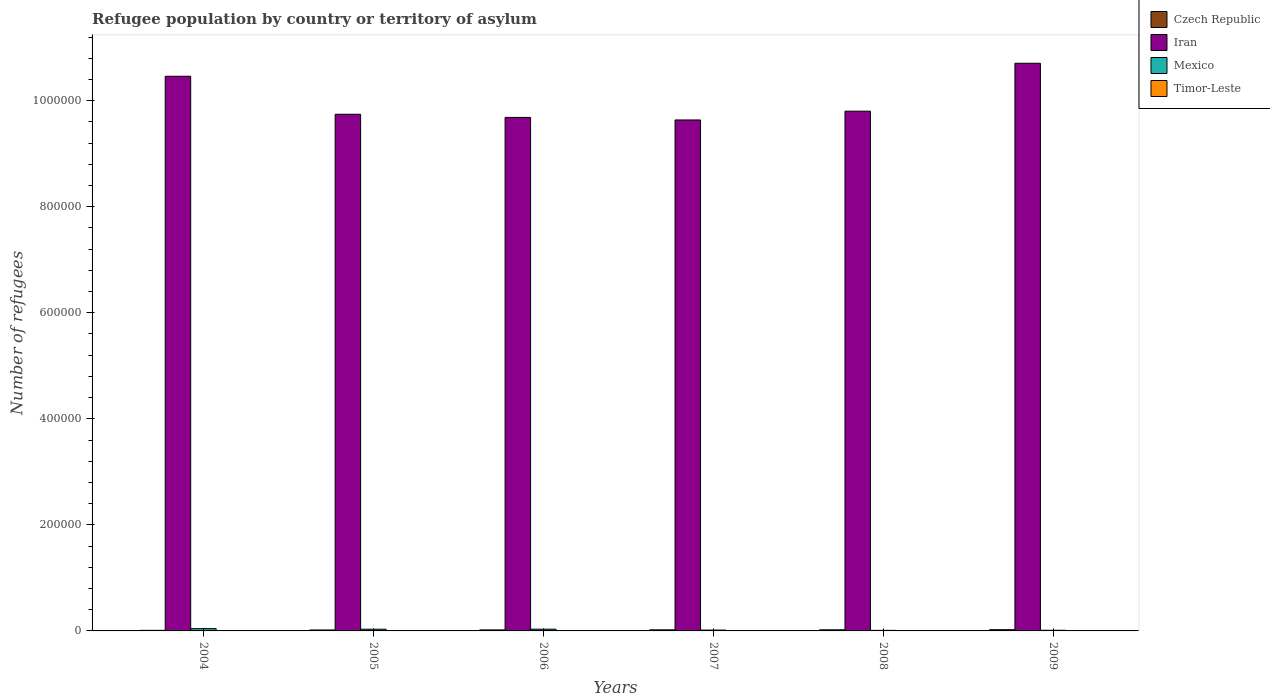How many different coloured bars are there?
Your answer should be very brief. 4. What is the label of the 4th group of bars from the left?
Offer a very short reply. 2007. What is the number of refugees in Czech Republic in 2007?
Offer a very short reply. 2037. Across all years, what is the minimum number of refugees in Mexico?
Offer a very short reply. 1055. In which year was the number of refugees in Iran maximum?
Offer a terse response. 2009. In which year was the number of refugees in Iran minimum?
Offer a terse response. 2007. What is the total number of refugees in Mexico in the graph?
Offer a very short reply. 1.48e+04. What is the difference between the number of refugees in Iran in 2006 and the number of refugees in Czech Republic in 2004?
Provide a short and direct response. 9.67e+05. What is the average number of refugees in Mexico per year?
Make the answer very short. 2466.17. In the year 2005, what is the difference between the number of refugees in Mexico and number of refugees in Timor-Leste?
Keep it short and to the point. 3226. What is the ratio of the number of refugees in Czech Republic in 2008 to that in 2009?
Offer a terse response. 0.91. Is the number of refugees in Iran in 2004 less than that in 2008?
Your response must be concise. No. Is the difference between the number of refugees in Mexico in 2006 and 2009 greater than the difference between the number of refugees in Timor-Leste in 2006 and 2009?
Give a very brief answer. Yes. What is the difference between the highest and the second highest number of refugees in Czech Republic?
Offer a terse response. 213. What is the difference between the highest and the lowest number of refugees in Mexico?
Provide a short and direct response. 3288. Is the sum of the number of refugees in Timor-Leste in 2007 and 2008 greater than the maximum number of refugees in Iran across all years?
Provide a succinct answer. No. Is it the case that in every year, the sum of the number of refugees in Czech Republic and number of refugees in Iran is greater than the sum of number of refugees in Mexico and number of refugees in Timor-Leste?
Your answer should be very brief. Yes. What does the 1st bar from the left in 2004 represents?
Give a very brief answer. Czech Republic. What is the difference between two consecutive major ticks on the Y-axis?
Make the answer very short. 2.00e+05. Are the values on the major ticks of Y-axis written in scientific E-notation?
Keep it short and to the point. No. Does the graph contain grids?
Provide a succinct answer. No. What is the title of the graph?
Make the answer very short. Refugee population by country or territory of asylum. What is the label or title of the X-axis?
Provide a succinct answer. Years. What is the label or title of the Y-axis?
Your response must be concise. Number of refugees. What is the Number of refugees in Czech Republic in 2004?
Your answer should be very brief. 1144. What is the Number of refugees of Iran in 2004?
Your response must be concise. 1.05e+06. What is the Number of refugees in Mexico in 2004?
Offer a terse response. 4343. What is the Number of refugees of Timor-Leste in 2004?
Make the answer very short. 3. What is the Number of refugees of Czech Republic in 2005?
Offer a terse response. 1802. What is the Number of refugees of Iran in 2005?
Your answer should be very brief. 9.74e+05. What is the Number of refugees of Mexico in 2005?
Provide a succinct answer. 3229. What is the Number of refugees in Czech Republic in 2006?
Offer a terse response. 1887. What is the Number of refugees of Iran in 2006?
Keep it short and to the point. 9.68e+05. What is the Number of refugees in Mexico in 2006?
Your response must be concise. 3319. What is the Number of refugees in Timor-Leste in 2006?
Your answer should be compact. 3. What is the Number of refugees in Czech Republic in 2007?
Your response must be concise. 2037. What is the Number of refugees in Iran in 2007?
Give a very brief answer. 9.64e+05. What is the Number of refugees of Mexico in 2007?
Provide a short and direct response. 1616. What is the Number of refugees of Timor-Leste in 2007?
Give a very brief answer. 1. What is the Number of refugees of Czech Republic in 2008?
Ensure brevity in your answer.  2110. What is the Number of refugees in Iran in 2008?
Your answer should be very brief. 9.80e+05. What is the Number of refugees of Mexico in 2008?
Give a very brief answer. 1055. What is the Number of refugees of Timor-Leste in 2008?
Keep it short and to the point. 1. What is the Number of refugees in Czech Republic in 2009?
Provide a short and direct response. 2323. What is the Number of refugees in Iran in 2009?
Give a very brief answer. 1.07e+06. What is the Number of refugees in Mexico in 2009?
Your answer should be very brief. 1235. What is the Number of refugees in Timor-Leste in 2009?
Your answer should be compact. 1. Across all years, what is the maximum Number of refugees of Czech Republic?
Provide a short and direct response. 2323. Across all years, what is the maximum Number of refugees in Iran?
Keep it short and to the point. 1.07e+06. Across all years, what is the maximum Number of refugees of Mexico?
Provide a short and direct response. 4343. Across all years, what is the minimum Number of refugees in Czech Republic?
Your answer should be very brief. 1144. Across all years, what is the minimum Number of refugees in Iran?
Offer a very short reply. 9.64e+05. Across all years, what is the minimum Number of refugees of Mexico?
Ensure brevity in your answer.  1055. Across all years, what is the minimum Number of refugees in Timor-Leste?
Your answer should be very brief. 1. What is the total Number of refugees in Czech Republic in the graph?
Offer a very short reply. 1.13e+04. What is the total Number of refugees in Iran in the graph?
Your answer should be compact. 6.00e+06. What is the total Number of refugees of Mexico in the graph?
Your response must be concise. 1.48e+04. What is the difference between the Number of refugees in Czech Republic in 2004 and that in 2005?
Your answer should be compact. -658. What is the difference between the Number of refugees of Iran in 2004 and that in 2005?
Provide a succinct answer. 7.17e+04. What is the difference between the Number of refugees in Mexico in 2004 and that in 2005?
Ensure brevity in your answer.  1114. What is the difference between the Number of refugees of Czech Republic in 2004 and that in 2006?
Ensure brevity in your answer.  -743. What is the difference between the Number of refugees of Iran in 2004 and that in 2006?
Your answer should be compact. 7.76e+04. What is the difference between the Number of refugees of Mexico in 2004 and that in 2006?
Make the answer very short. 1024. What is the difference between the Number of refugees of Timor-Leste in 2004 and that in 2006?
Ensure brevity in your answer.  0. What is the difference between the Number of refugees in Czech Republic in 2004 and that in 2007?
Your answer should be compact. -893. What is the difference between the Number of refugees of Iran in 2004 and that in 2007?
Make the answer very short. 8.24e+04. What is the difference between the Number of refugees in Mexico in 2004 and that in 2007?
Ensure brevity in your answer.  2727. What is the difference between the Number of refugees of Czech Republic in 2004 and that in 2008?
Give a very brief answer. -966. What is the difference between the Number of refugees of Iran in 2004 and that in 2008?
Offer a terse response. 6.59e+04. What is the difference between the Number of refugees of Mexico in 2004 and that in 2008?
Provide a short and direct response. 3288. What is the difference between the Number of refugees in Timor-Leste in 2004 and that in 2008?
Keep it short and to the point. 2. What is the difference between the Number of refugees of Czech Republic in 2004 and that in 2009?
Provide a short and direct response. -1179. What is the difference between the Number of refugees in Iran in 2004 and that in 2009?
Offer a very short reply. -2.45e+04. What is the difference between the Number of refugees in Mexico in 2004 and that in 2009?
Your answer should be compact. 3108. What is the difference between the Number of refugees of Czech Republic in 2005 and that in 2006?
Give a very brief answer. -85. What is the difference between the Number of refugees in Iran in 2005 and that in 2006?
Ensure brevity in your answer.  5932. What is the difference between the Number of refugees in Mexico in 2005 and that in 2006?
Provide a succinct answer. -90. What is the difference between the Number of refugees in Timor-Leste in 2005 and that in 2006?
Offer a terse response. 0. What is the difference between the Number of refugees of Czech Republic in 2005 and that in 2007?
Provide a short and direct response. -235. What is the difference between the Number of refugees of Iran in 2005 and that in 2007?
Offer a very short reply. 1.08e+04. What is the difference between the Number of refugees in Mexico in 2005 and that in 2007?
Give a very brief answer. 1613. What is the difference between the Number of refugees of Czech Republic in 2005 and that in 2008?
Provide a succinct answer. -308. What is the difference between the Number of refugees of Iran in 2005 and that in 2008?
Your response must be concise. -5807. What is the difference between the Number of refugees in Mexico in 2005 and that in 2008?
Your answer should be very brief. 2174. What is the difference between the Number of refugees of Timor-Leste in 2005 and that in 2008?
Make the answer very short. 2. What is the difference between the Number of refugees in Czech Republic in 2005 and that in 2009?
Ensure brevity in your answer.  -521. What is the difference between the Number of refugees in Iran in 2005 and that in 2009?
Provide a short and direct response. -9.62e+04. What is the difference between the Number of refugees in Mexico in 2005 and that in 2009?
Make the answer very short. 1994. What is the difference between the Number of refugees in Timor-Leste in 2005 and that in 2009?
Make the answer very short. 2. What is the difference between the Number of refugees of Czech Republic in 2006 and that in 2007?
Offer a very short reply. -150. What is the difference between the Number of refugees of Iran in 2006 and that in 2007?
Offer a very short reply. 4824. What is the difference between the Number of refugees in Mexico in 2006 and that in 2007?
Your answer should be compact. 1703. What is the difference between the Number of refugees of Timor-Leste in 2006 and that in 2007?
Make the answer very short. 2. What is the difference between the Number of refugees in Czech Republic in 2006 and that in 2008?
Your response must be concise. -223. What is the difference between the Number of refugees in Iran in 2006 and that in 2008?
Give a very brief answer. -1.17e+04. What is the difference between the Number of refugees of Mexico in 2006 and that in 2008?
Your answer should be compact. 2264. What is the difference between the Number of refugees in Timor-Leste in 2006 and that in 2008?
Your answer should be compact. 2. What is the difference between the Number of refugees of Czech Republic in 2006 and that in 2009?
Provide a short and direct response. -436. What is the difference between the Number of refugees of Iran in 2006 and that in 2009?
Your answer should be very brief. -1.02e+05. What is the difference between the Number of refugees of Mexico in 2006 and that in 2009?
Give a very brief answer. 2084. What is the difference between the Number of refugees of Timor-Leste in 2006 and that in 2009?
Make the answer very short. 2. What is the difference between the Number of refugees in Czech Republic in 2007 and that in 2008?
Keep it short and to the point. -73. What is the difference between the Number of refugees of Iran in 2007 and that in 2008?
Offer a very short reply. -1.66e+04. What is the difference between the Number of refugees of Mexico in 2007 and that in 2008?
Your response must be concise. 561. What is the difference between the Number of refugees in Czech Republic in 2007 and that in 2009?
Your answer should be very brief. -286. What is the difference between the Number of refugees of Iran in 2007 and that in 2009?
Your answer should be very brief. -1.07e+05. What is the difference between the Number of refugees of Mexico in 2007 and that in 2009?
Ensure brevity in your answer.  381. What is the difference between the Number of refugees in Timor-Leste in 2007 and that in 2009?
Provide a succinct answer. 0. What is the difference between the Number of refugees in Czech Republic in 2008 and that in 2009?
Your response must be concise. -213. What is the difference between the Number of refugees in Iran in 2008 and that in 2009?
Give a very brief answer. -9.04e+04. What is the difference between the Number of refugees in Mexico in 2008 and that in 2009?
Make the answer very short. -180. What is the difference between the Number of refugees in Czech Republic in 2004 and the Number of refugees in Iran in 2005?
Keep it short and to the point. -9.73e+05. What is the difference between the Number of refugees in Czech Republic in 2004 and the Number of refugees in Mexico in 2005?
Ensure brevity in your answer.  -2085. What is the difference between the Number of refugees of Czech Republic in 2004 and the Number of refugees of Timor-Leste in 2005?
Provide a short and direct response. 1141. What is the difference between the Number of refugees in Iran in 2004 and the Number of refugees in Mexico in 2005?
Ensure brevity in your answer.  1.04e+06. What is the difference between the Number of refugees of Iran in 2004 and the Number of refugees of Timor-Leste in 2005?
Your answer should be compact. 1.05e+06. What is the difference between the Number of refugees in Mexico in 2004 and the Number of refugees in Timor-Leste in 2005?
Your answer should be very brief. 4340. What is the difference between the Number of refugees of Czech Republic in 2004 and the Number of refugees of Iran in 2006?
Your answer should be very brief. -9.67e+05. What is the difference between the Number of refugees in Czech Republic in 2004 and the Number of refugees in Mexico in 2006?
Your response must be concise. -2175. What is the difference between the Number of refugees in Czech Republic in 2004 and the Number of refugees in Timor-Leste in 2006?
Provide a succinct answer. 1141. What is the difference between the Number of refugees of Iran in 2004 and the Number of refugees of Mexico in 2006?
Ensure brevity in your answer.  1.04e+06. What is the difference between the Number of refugees in Iran in 2004 and the Number of refugees in Timor-Leste in 2006?
Your answer should be compact. 1.05e+06. What is the difference between the Number of refugees of Mexico in 2004 and the Number of refugees of Timor-Leste in 2006?
Provide a succinct answer. 4340. What is the difference between the Number of refugees in Czech Republic in 2004 and the Number of refugees in Iran in 2007?
Offer a very short reply. -9.62e+05. What is the difference between the Number of refugees in Czech Republic in 2004 and the Number of refugees in Mexico in 2007?
Your response must be concise. -472. What is the difference between the Number of refugees of Czech Republic in 2004 and the Number of refugees of Timor-Leste in 2007?
Offer a very short reply. 1143. What is the difference between the Number of refugees of Iran in 2004 and the Number of refugees of Mexico in 2007?
Your answer should be compact. 1.04e+06. What is the difference between the Number of refugees of Iran in 2004 and the Number of refugees of Timor-Leste in 2007?
Offer a terse response. 1.05e+06. What is the difference between the Number of refugees in Mexico in 2004 and the Number of refugees in Timor-Leste in 2007?
Your response must be concise. 4342. What is the difference between the Number of refugees of Czech Republic in 2004 and the Number of refugees of Iran in 2008?
Your answer should be compact. -9.79e+05. What is the difference between the Number of refugees in Czech Republic in 2004 and the Number of refugees in Mexico in 2008?
Your response must be concise. 89. What is the difference between the Number of refugees of Czech Republic in 2004 and the Number of refugees of Timor-Leste in 2008?
Your response must be concise. 1143. What is the difference between the Number of refugees in Iran in 2004 and the Number of refugees in Mexico in 2008?
Offer a terse response. 1.04e+06. What is the difference between the Number of refugees of Iran in 2004 and the Number of refugees of Timor-Leste in 2008?
Keep it short and to the point. 1.05e+06. What is the difference between the Number of refugees in Mexico in 2004 and the Number of refugees in Timor-Leste in 2008?
Give a very brief answer. 4342. What is the difference between the Number of refugees in Czech Republic in 2004 and the Number of refugees in Iran in 2009?
Give a very brief answer. -1.07e+06. What is the difference between the Number of refugees in Czech Republic in 2004 and the Number of refugees in Mexico in 2009?
Provide a short and direct response. -91. What is the difference between the Number of refugees of Czech Republic in 2004 and the Number of refugees of Timor-Leste in 2009?
Offer a terse response. 1143. What is the difference between the Number of refugees of Iran in 2004 and the Number of refugees of Mexico in 2009?
Offer a terse response. 1.04e+06. What is the difference between the Number of refugees in Iran in 2004 and the Number of refugees in Timor-Leste in 2009?
Offer a very short reply. 1.05e+06. What is the difference between the Number of refugees of Mexico in 2004 and the Number of refugees of Timor-Leste in 2009?
Your response must be concise. 4342. What is the difference between the Number of refugees of Czech Republic in 2005 and the Number of refugees of Iran in 2006?
Make the answer very short. -9.67e+05. What is the difference between the Number of refugees of Czech Republic in 2005 and the Number of refugees of Mexico in 2006?
Your response must be concise. -1517. What is the difference between the Number of refugees in Czech Republic in 2005 and the Number of refugees in Timor-Leste in 2006?
Offer a terse response. 1799. What is the difference between the Number of refugees of Iran in 2005 and the Number of refugees of Mexico in 2006?
Your response must be concise. 9.71e+05. What is the difference between the Number of refugees in Iran in 2005 and the Number of refugees in Timor-Leste in 2006?
Keep it short and to the point. 9.74e+05. What is the difference between the Number of refugees in Mexico in 2005 and the Number of refugees in Timor-Leste in 2006?
Your answer should be compact. 3226. What is the difference between the Number of refugees of Czech Republic in 2005 and the Number of refugees of Iran in 2007?
Provide a succinct answer. -9.62e+05. What is the difference between the Number of refugees in Czech Republic in 2005 and the Number of refugees in Mexico in 2007?
Make the answer very short. 186. What is the difference between the Number of refugees in Czech Republic in 2005 and the Number of refugees in Timor-Leste in 2007?
Offer a very short reply. 1801. What is the difference between the Number of refugees of Iran in 2005 and the Number of refugees of Mexico in 2007?
Your answer should be compact. 9.73e+05. What is the difference between the Number of refugees of Iran in 2005 and the Number of refugees of Timor-Leste in 2007?
Your answer should be very brief. 9.74e+05. What is the difference between the Number of refugees of Mexico in 2005 and the Number of refugees of Timor-Leste in 2007?
Your answer should be very brief. 3228. What is the difference between the Number of refugees of Czech Republic in 2005 and the Number of refugees of Iran in 2008?
Provide a short and direct response. -9.78e+05. What is the difference between the Number of refugees in Czech Republic in 2005 and the Number of refugees in Mexico in 2008?
Your answer should be very brief. 747. What is the difference between the Number of refugees of Czech Republic in 2005 and the Number of refugees of Timor-Leste in 2008?
Provide a short and direct response. 1801. What is the difference between the Number of refugees of Iran in 2005 and the Number of refugees of Mexico in 2008?
Keep it short and to the point. 9.73e+05. What is the difference between the Number of refugees in Iran in 2005 and the Number of refugees in Timor-Leste in 2008?
Give a very brief answer. 9.74e+05. What is the difference between the Number of refugees in Mexico in 2005 and the Number of refugees in Timor-Leste in 2008?
Offer a very short reply. 3228. What is the difference between the Number of refugees in Czech Republic in 2005 and the Number of refugees in Iran in 2009?
Offer a terse response. -1.07e+06. What is the difference between the Number of refugees of Czech Republic in 2005 and the Number of refugees of Mexico in 2009?
Your answer should be very brief. 567. What is the difference between the Number of refugees in Czech Republic in 2005 and the Number of refugees in Timor-Leste in 2009?
Give a very brief answer. 1801. What is the difference between the Number of refugees in Iran in 2005 and the Number of refugees in Mexico in 2009?
Your answer should be very brief. 9.73e+05. What is the difference between the Number of refugees in Iran in 2005 and the Number of refugees in Timor-Leste in 2009?
Offer a terse response. 9.74e+05. What is the difference between the Number of refugees in Mexico in 2005 and the Number of refugees in Timor-Leste in 2009?
Make the answer very short. 3228. What is the difference between the Number of refugees in Czech Republic in 2006 and the Number of refugees in Iran in 2007?
Ensure brevity in your answer.  -9.62e+05. What is the difference between the Number of refugees of Czech Republic in 2006 and the Number of refugees of Mexico in 2007?
Make the answer very short. 271. What is the difference between the Number of refugees of Czech Republic in 2006 and the Number of refugees of Timor-Leste in 2007?
Provide a succinct answer. 1886. What is the difference between the Number of refugees of Iran in 2006 and the Number of refugees of Mexico in 2007?
Offer a very short reply. 9.67e+05. What is the difference between the Number of refugees in Iran in 2006 and the Number of refugees in Timor-Leste in 2007?
Ensure brevity in your answer.  9.68e+05. What is the difference between the Number of refugees of Mexico in 2006 and the Number of refugees of Timor-Leste in 2007?
Offer a very short reply. 3318. What is the difference between the Number of refugees of Czech Republic in 2006 and the Number of refugees of Iran in 2008?
Make the answer very short. -9.78e+05. What is the difference between the Number of refugees of Czech Republic in 2006 and the Number of refugees of Mexico in 2008?
Offer a terse response. 832. What is the difference between the Number of refugees of Czech Republic in 2006 and the Number of refugees of Timor-Leste in 2008?
Your answer should be very brief. 1886. What is the difference between the Number of refugees in Iran in 2006 and the Number of refugees in Mexico in 2008?
Give a very brief answer. 9.67e+05. What is the difference between the Number of refugees in Iran in 2006 and the Number of refugees in Timor-Leste in 2008?
Your answer should be very brief. 9.68e+05. What is the difference between the Number of refugees of Mexico in 2006 and the Number of refugees of Timor-Leste in 2008?
Ensure brevity in your answer.  3318. What is the difference between the Number of refugees of Czech Republic in 2006 and the Number of refugees of Iran in 2009?
Your answer should be compact. -1.07e+06. What is the difference between the Number of refugees of Czech Republic in 2006 and the Number of refugees of Mexico in 2009?
Provide a succinct answer. 652. What is the difference between the Number of refugees of Czech Republic in 2006 and the Number of refugees of Timor-Leste in 2009?
Your response must be concise. 1886. What is the difference between the Number of refugees of Iran in 2006 and the Number of refugees of Mexico in 2009?
Keep it short and to the point. 9.67e+05. What is the difference between the Number of refugees in Iran in 2006 and the Number of refugees in Timor-Leste in 2009?
Provide a succinct answer. 9.68e+05. What is the difference between the Number of refugees in Mexico in 2006 and the Number of refugees in Timor-Leste in 2009?
Offer a terse response. 3318. What is the difference between the Number of refugees of Czech Republic in 2007 and the Number of refugees of Iran in 2008?
Your response must be concise. -9.78e+05. What is the difference between the Number of refugees of Czech Republic in 2007 and the Number of refugees of Mexico in 2008?
Your response must be concise. 982. What is the difference between the Number of refugees in Czech Republic in 2007 and the Number of refugees in Timor-Leste in 2008?
Give a very brief answer. 2036. What is the difference between the Number of refugees in Iran in 2007 and the Number of refugees in Mexico in 2008?
Give a very brief answer. 9.62e+05. What is the difference between the Number of refugees of Iran in 2007 and the Number of refugees of Timor-Leste in 2008?
Provide a short and direct response. 9.64e+05. What is the difference between the Number of refugees in Mexico in 2007 and the Number of refugees in Timor-Leste in 2008?
Your answer should be compact. 1615. What is the difference between the Number of refugees of Czech Republic in 2007 and the Number of refugees of Iran in 2009?
Offer a terse response. -1.07e+06. What is the difference between the Number of refugees of Czech Republic in 2007 and the Number of refugees of Mexico in 2009?
Offer a very short reply. 802. What is the difference between the Number of refugees in Czech Republic in 2007 and the Number of refugees in Timor-Leste in 2009?
Provide a succinct answer. 2036. What is the difference between the Number of refugees of Iran in 2007 and the Number of refugees of Mexico in 2009?
Your answer should be compact. 9.62e+05. What is the difference between the Number of refugees in Iran in 2007 and the Number of refugees in Timor-Leste in 2009?
Your answer should be compact. 9.64e+05. What is the difference between the Number of refugees of Mexico in 2007 and the Number of refugees of Timor-Leste in 2009?
Your answer should be very brief. 1615. What is the difference between the Number of refugees of Czech Republic in 2008 and the Number of refugees of Iran in 2009?
Provide a short and direct response. -1.07e+06. What is the difference between the Number of refugees of Czech Republic in 2008 and the Number of refugees of Mexico in 2009?
Offer a terse response. 875. What is the difference between the Number of refugees of Czech Republic in 2008 and the Number of refugees of Timor-Leste in 2009?
Your answer should be compact. 2109. What is the difference between the Number of refugees in Iran in 2008 and the Number of refugees in Mexico in 2009?
Offer a terse response. 9.79e+05. What is the difference between the Number of refugees of Iran in 2008 and the Number of refugees of Timor-Leste in 2009?
Provide a succinct answer. 9.80e+05. What is the difference between the Number of refugees in Mexico in 2008 and the Number of refugees in Timor-Leste in 2009?
Give a very brief answer. 1054. What is the average Number of refugees of Czech Republic per year?
Your answer should be compact. 1883.83. What is the average Number of refugees of Iran per year?
Keep it short and to the point. 1.00e+06. What is the average Number of refugees in Mexico per year?
Your response must be concise. 2466.17. What is the average Number of refugees of Timor-Leste per year?
Give a very brief answer. 2. In the year 2004, what is the difference between the Number of refugees of Czech Republic and Number of refugees of Iran?
Your response must be concise. -1.04e+06. In the year 2004, what is the difference between the Number of refugees in Czech Republic and Number of refugees in Mexico?
Keep it short and to the point. -3199. In the year 2004, what is the difference between the Number of refugees of Czech Republic and Number of refugees of Timor-Leste?
Offer a very short reply. 1141. In the year 2004, what is the difference between the Number of refugees of Iran and Number of refugees of Mexico?
Give a very brief answer. 1.04e+06. In the year 2004, what is the difference between the Number of refugees of Iran and Number of refugees of Timor-Leste?
Offer a terse response. 1.05e+06. In the year 2004, what is the difference between the Number of refugees of Mexico and Number of refugees of Timor-Leste?
Your response must be concise. 4340. In the year 2005, what is the difference between the Number of refugees in Czech Republic and Number of refugees in Iran?
Ensure brevity in your answer.  -9.72e+05. In the year 2005, what is the difference between the Number of refugees of Czech Republic and Number of refugees of Mexico?
Keep it short and to the point. -1427. In the year 2005, what is the difference between the Number of refugees in Czech Republic and Number of refugees in Timor-Leste?
Offer a terse response. 1799. In the year 2005, what is the difference between the Number of refugees of Iran and Number of refugees of Mexico?
Provide a short and direct response. 9.71e+05. In the year 2005, what is the difference between the Number of refugees of Iran and Number of refugees of Timor-Leste?
Ensure brevity in your answer.  9.74e+05. In the year 2005, what is the difference between the Number of refugees in Mexico and Number of refugees in Timor-Leste?
Your answer should be compact. 3226. In the year 2006, what is the difference between the Number of refugees in Czech Republic and Number of refugees in Iran?
Keep it short and to the point. -9.66e+05. In the year 2006, what is the difference between the Number of refugees in Czech Republic and Number of refugees in Mexico?
Your answer should be compact. -1432. In the year 2006, what is the difference between the Number of refugees in Czech Republic and Number of refugees in Timor-Leste?
Your answer should be compact. 1884. In the year 2006, what is the difference between the Number of refugees in Iran and Number of refugees in Mexico?
Provide a short and direct response. 9.65e+05. In the year 2006, what is the difference between the Number of refugees of Iran and Number of refugees of Timor-Leste?
Give a very brief answer. 9.68e+05. In the year 2006, what is the difference between the Number of refugees in Mexico and Number of refugees in Timor-Leste?
Make the answer very short. 3316. In the year 2007, what is the difference between the Number of refugees of Czech Republic and Number of refugees of Iran?
Provide a short and direct response. -9.62e+05. In the year 2007, what is the difference between the Number of refugees of Czech Republic and Number of refugees of Mexico?
Your answer should be very brief. 421. In the year 2007, what is the difference between the Number of refugees in Czech Republic and Number of refugees in Timor-Leste?
Your answer should be compact. 2036. In the year 2007, what is the difference between the Number of refugees in Iran and Number of refugees in Mexico?
Ensure brevity in your answer.  9.62e+05. In the year 2007, what is the difference between the Number of refugees of Iran and Number of refugees of Timor-Leste?
Give a very brief answer. 9.64e+05. In the year 2007, what is the difference between the Number of refugees in Mexico and Number of refugees in Timor-Leste?
Give a very brief answer. 1615. In the year 2008, what is the difference between the Number of refugees of Czech Republic and Number of refugees of Iran?
Make the answer very short. -9.78e+05. In the year 2008, what is the difference between the Number of refugees of Czech Republic and Number of refugees of Mexico?
Your answer should be very brief. 1055. In the year 2008, what is the difference between the Number of refugees in Czech Republic and Number of refugees in Timor-Leste?
Your answer should be compact. 2109. In the year 2008, what is the difference between the Number of refugees in Iran and Number of refugees in Mexico?
Offer a terse response. 9.79e+05. In the year 2008, what is the difference between the Number of refugees in Iran and Number of refugees in Timor-Leste?
Ensure brevity in your answer.  9.80e+05. In the year 2008, what is the difference between the Number of refugees of Mexico and Number of refugees of Timor-Leste?
Make the answer very short. 1054. In the year 2009, what is the difference between the Number of refugees of Czech Republic and Number of refugees of Iran?
Keep it short and to the point. -1.07e+06. In the year 2009, what is the difference between the Number of refugees in Czech Republic and Number of refugees in Mexico?
Make the answer very short. 1088. In the year 2009, what is the difference between the Number of refugees in Czech Republic and Number of refugees in Timor-Leste?
Provide a succinct answer. 2322. In the year 2009, what is the difference between the Number of refugees in Iran and Number of refugees in Mexico?
Your response must be concise. 1.07e+06. In the year 2009, what is the difference between the Number of refugees in Iran and Number of refugees in Timor-Leste?
Offer a terse response. 1.07e+06. In the year 2009, what is the difference between the Number of refugees of Mexico and Number of refugees of Timor-Leste?
Offer a very short reply. 1234. What is the ratio of the Number of refugees in Czech Republic in 2004 to that in 2005?
Your answer should be compact. 0.63. What is the ratio of the Number of refugees in Iran in 2004 to that in 2005?
Your answer should be very brief. 1.07. What is the ratio of the Number of refugees in Mexico in 2004 to that in 2005?
Keep it short and to the point. 1.34. What is the ratio of the Number of refugees of Czech Republic in 2004 to that in 2006?
Keep it short and to the point. 0.61. What is the ratio of the Number of refugees of Iran in 2004 to that in 2006?
Your answer should be compact. 1.08. What is the ratio of the Number of refugees in Mexico in 2004 to that in 2006?
Make the answer very short. 1.31. What is the ratio of the Number of refugees of Timor-Leste in 2004 to that in 2006?
Keep it short and to the point. 1. What is the ratio of the Number of refugees in Czech Republic in 2004 to that in 2007?
Give a very brief answer. 0.56. What is the ratio of the Number of refugees of Iran in 2004 to that in 2007?
Your response must be concise. 1.09. What is the ratio of the Number of refugees of Mexico in 2004 to that in 2007?
Your answer should be compact. 2.69. What is the ratio of the Number of refugees in Timor-Leste in 2004 to that in 2007?
Your answer should be compact. 3. What is the ratio of the Number of refugees of Czech Republic in 2004 to that in 2008?
Your answer should be compact. 0.54. What is the ratio of the Number of refugees of Iran in 2004 to that in 2008?
Your answer should be very brief. 1.07. What is the ratio of the Number of refugees in Mexico in 2004 to that in 2008?
Provide a succinct answer. 4.12. What is the ratio of the Number of refugees in Timor-Leste in 2004 to that in 2008?
Ensure brevity in your answer.  3. What is the ratio of the Number of refugees of Czech Republic in 2004 to that in 2009?
Offer a terse response. 0.49. What is the ratio of the Number of refugees in Iran in 2004 to that in 2009?
Keep it short and to the point. 0.98. What is the ratio of the Number of refugees in Mexico in 2004 to that in 2009?
Give a very brief answer. 3.52. What is the ratio of the Number of refugees of Czech Republic in 2005 to that in 2006?
Provide a short and direct response. 0.95. What is the ratio of the Number of refugees in Mexico in 2005 to that in 2006?
Your response must be concise. 0.97. What is the ratio of the Number of refugees in Timor-Leste in 2005 to that in 2006?
Keep it short and to the point. 1. What is the ratio of the Number of refugees in Czech Republic in 2005 to that in 2007?
Your answer should be compact. 0.88. What is the ratio of the Number of refugees of Iran in 2005 to that in 2007?
Provide a succinct answer. 1.01. What is the ratio of the Number of refugees in Mexico in 2005 to that in 2007?
Provide a short and direct response. 2. What is the ratio of the Number of refugees of Timor-Leste in 2005 to that in 2007?
Offer a terse response. 3. What is the ratio of the Number of refugees in Czech Republic in 2005 to that in 2008?
Your answer should be compact. 0.85. What is the ratio of the Number of refugees of Iran in 2005 to that in 2008?
Give a very brief answer. 0.99. What is the ratio of the Number of refugees in Mexico in 2005 to that in 2008?
Ensure brevity in your answer.  3.06. What is the ratio of the Number of refugees in Czech Republic in 2005 to that in 2009?
Ensure brevity in your answer.  0.78. What is the ratio of the Number of refugees in Iran in 2005 to that in 2009?
Your answer should be compact. 0.91. What is the ratio of the Number of refugees of Mexico in 2005 to that in 2009?
Your answer should be very brief. 2.61. What is the ratio of the Number of refugees of Timor-Leste in 2005 to that in 2009?
Provide a short and direct response. 3. What is the ratio of the Number of refugees of Czech Republic in 2006 to that in 2007?
Your answer should be very brief. 0.93. What is the ratio of the Number of refugees of Mexico in 2006 to that in 2007?
Your answer should be compact. 2.05. What is the ratio of the Number of refugees of Czech Republic in 2006 to that in 2008?
Your response must be concise. 0.89. What is the ratio of the Number of refugees in Mexico in 2006 to that in 2008?
Your answer should be very brief. 3.15. What is the ratio of the Number of refugees of Timor-Leste in 2006 to that in 2008?
Give a very brief answer. 3. What is the ratio of the Number of refugees in Czech Republic in 2006 to that in 2009?
Provide a short and direct response. 0.81. What is the ratio of the Number of refugees of Iran in 2006 to that in 2009?
Offer a terse response. 0.9. What is the ratio of the Number of refugees of Mexico in 2006 to that in 2009?
Provide a short and direct response. 2.69. What is the ratio of the Number of refugees of Czech Republic in 2007 to that in 2008?
Offer a terse response. 0.97. What is the ratio of the Number of refugees of Iran in 2007 to that in 2008?
Offer a very short reply. 0.98. What is the ratio of the Number of refugees in Mexico in 2007 to that in 2008?
Offer a terse response. 1.53. What is the ratio of the Number of refugees in Czech Republic in 2007 to that in 2009?
Offer a very short reply. 0.88. What is the ratio of the Number of refugees in Iran in 2007 to that in 2009?
Keep it short and to the point. 0.9. What is the ratio of the Number of refugees in Mexico in 2007 to that in 2009?
Give a very brief answer. 1.31. What is the ratio of the Number of refugees in Czech Republic in 2008 to that in 2009?
Your response must be concise. 0.91. What is the ratio of the Number of refugees of Iran in 2008 to that in 2009?
Provide a short and direct response. 0.92. What is the ratio of the Number of refugees of Mexico in 2008 to that in 2009?
Provide a succinct answer. 0.85. What is the ratio of the Number of refugees in Timor-Leste in 2008 to that in 2009?
Ensure brevity in your answer.  1. What is the difference between the highest and the second highest Number of refugees in Czech Republic?
Make the answer very short. 213. What is the difference between the highest and the second highest Number of refugees in Iran?
Give a very brief answer. 2.45e+04. What is the difference between the highest and the second highest Number of refugees of Mexico?
Offer a terse response. 1024. What is the difference between the highest and the lowest Number of refugees in Czech Republic?
Offer a very short reply. 1179. What is the difference between the highest and the lowest Number of refugees of Iran?
Make the answer very short. 1.07e+05. What is the difference between the highest and the lowest Number of refugees in Mexico?
Provide a succinct answer. 3288. What is the difference between the highest and the lowest Number of refugees in Timor-Leste?
Your answer should be very brief. 2. 